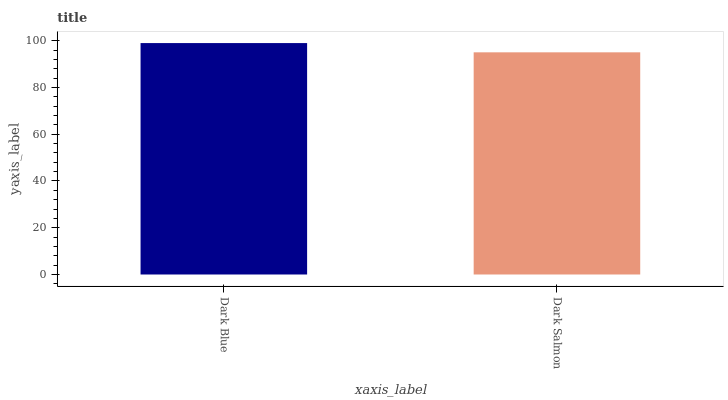Is Dark Salmon the maximum?
Answer yes or no. No. Is Dark Blue greater than Dark Salmon?
Answer yes or no. Yes. Is Dark Salmon less than Dark Blue?
Answer yes or no. Yes. Is Dark Salmon greater than Dark Blue?
Answer yes or no. No. Is Dark Blue less than Dark Salmon?
Answer yes or no. No. Is Dark Blue the high median?
Answer yes or no. Yes. Is Dark Salmon the low median?
Answer yes or no. Yes. Is Dark Salmon the high median?
Answer yes or no. No. Is Dark Blue the low median?
Answer yes or no. No. 